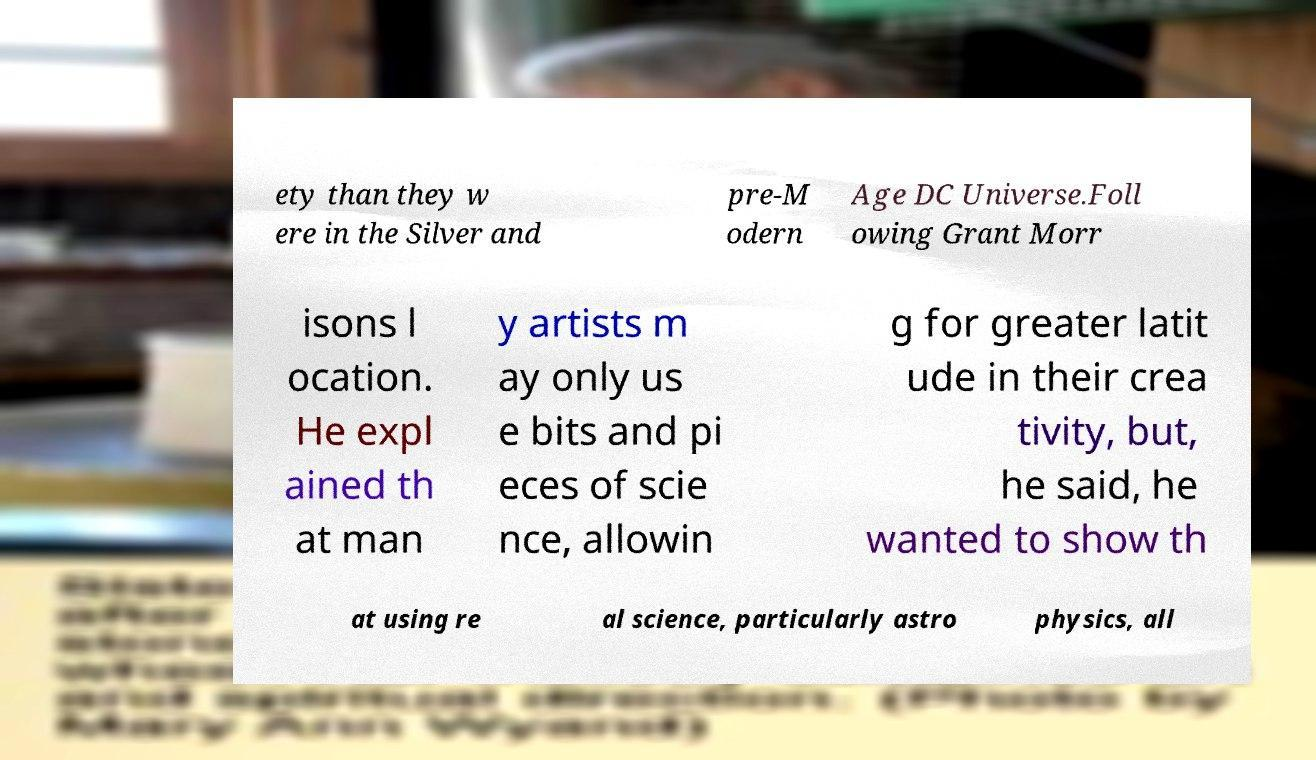Please identify and transcribe the text found in this image. ety than they w ere in the Silver and pre-M odern Age DC Universe.Foll owing Grant Morr isons l ocation. He expl ained th at man y artists m ay only us e bits and pi eces of scie nce, allowin g for greater latit ude in their crea tivity, but, he said, he wanted to show th at using re al science, particularly astro physics, all 